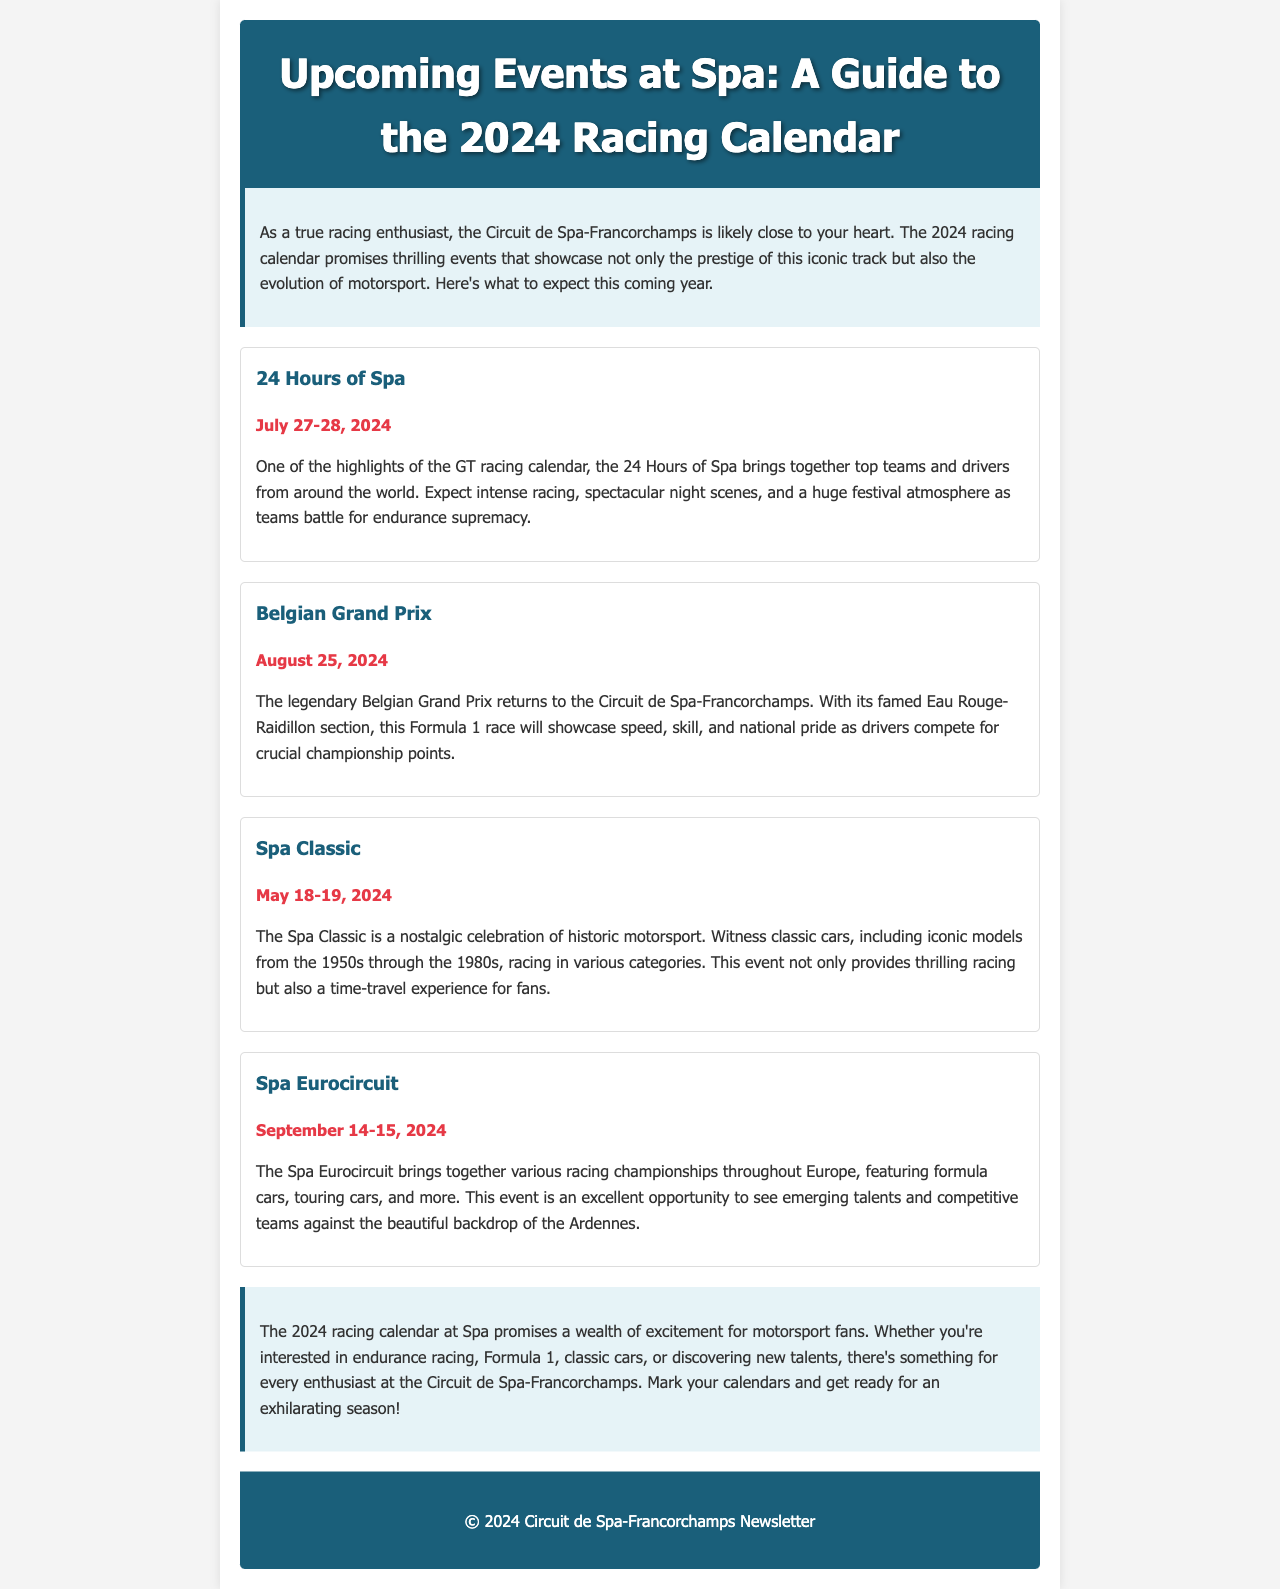What is the date of the 24 Hours of Spa? The date is mentioned directly under the event title, which is July 27-28, 2024.
Answer: July 27-28, 2024 Which event features classic cars from the 1950s through the 1980s? The document describes the Spa Classic as a nostalgic celebration of historic motorsport including these classic cars.
Answer: Spa Classic What is the date of the Belgian Grand Prix? The date is specifically listed under the event title for the Belgian Grand Prix, which is August 25, 2024.
Answer: August 25, 2024 How many events are listed in the 2024 racing calendar? There are four distinct events detailed in the document.
Answer: Four What type of racing does the Spa Eurocircuit feature? The document specifies that the Spa Eurocircuit includes various racing championships with formula cars, touring cars, and more.
Answer: Various racing championships What can you expect at the 24 Hours of Spa? The document highlights intense racing, spectacular night scenes, and a huge festival atmosphere.
Answer: Intense racing, spectacular night scenes, and a huge festival atmosphere When does the Spa Classic take place? The date for the Spa Classic is provided in the document, which is May 18-19, 2024.
Answer: May 18-19, 2024 What atmosphere is expected during the 2024 racing calendar at Spa? The document describes the atmosphere as exhilarating for motorsport fans, highlighting excitement for various events.
Answer: Exciting atmosphere for motorsport fans What is the primary theme of the introduction section? The introduction emphasizes the excitement surrounding the 2024 racing calendar at the Circuit de Spa-Francorchamps.
Answer: Excitement surrounding the 2024 racing calendar 